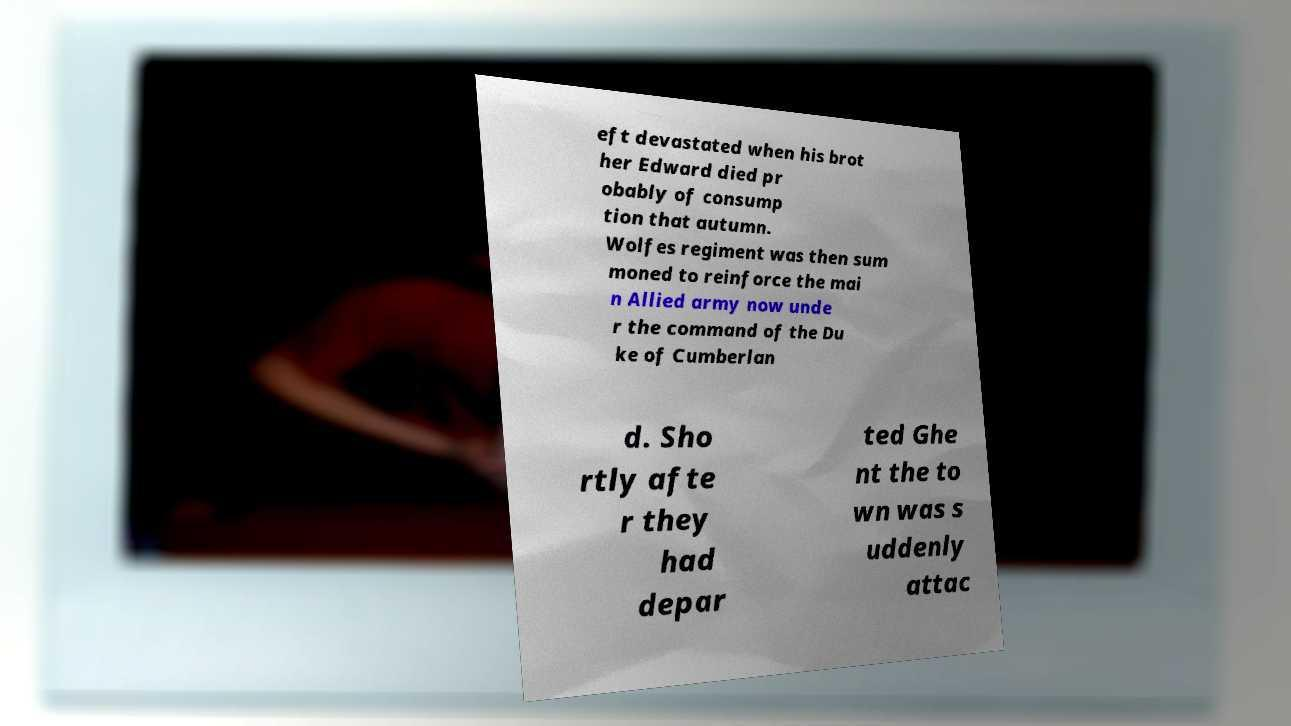Can you read and provide the text displayed in the image?This photo seems to have some interesting text. Can you extract and type it out for me? eft devastated when his brot her Edward died pr obably of consump tion that autumn. Wolfes regiment was then sum moned to reinforce the mai n Allied army now unde r the command of the Du ke of Cumberlan d. Sho rtly afte r they had depar ted Ghe nt the to wn was s uddenly attac 